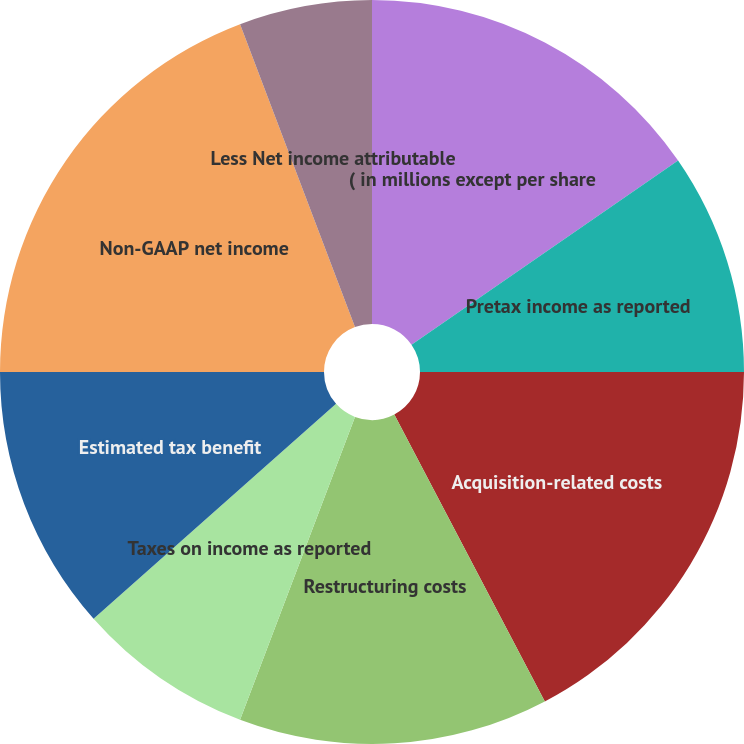<chart> <loc_0><loc_0><loc_500><loc_500><pie_chart><fcel>( in millions except per share<fcel>Pretax income as reported<fcel>Acquisition-related costs<fcel>Restructuring costs<fcel>Taxes on income as reported<fcel>Estimated tax benefit<fcel>Non-GAAP net income<fcel>Less Net income attributable<fcel>EPS assuming dilution as<nl><fcel>15.38%<fcel>9.62%<fcel>17.31%<fcel>13.46%<fcel>7.69%<fcel>11.54%<fcel>19.23%<fcel>5.77%<fcel>0.0%<nl></chart> 